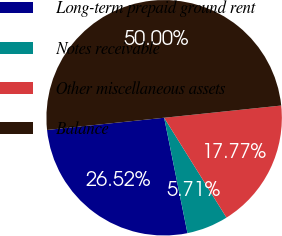Convert chart. <chart><loc_0><loc_0><loc_500><loc_500><pie_chart><fcel>Long-term prepaid ground rent<fcel>Notes receivable<fcel>Other miscellaneous assets<fcel>Balance<nl><fcel>26.52%<fcel>5.71%<fcel>17.77%<fcel>50.0%<nl></chart> 